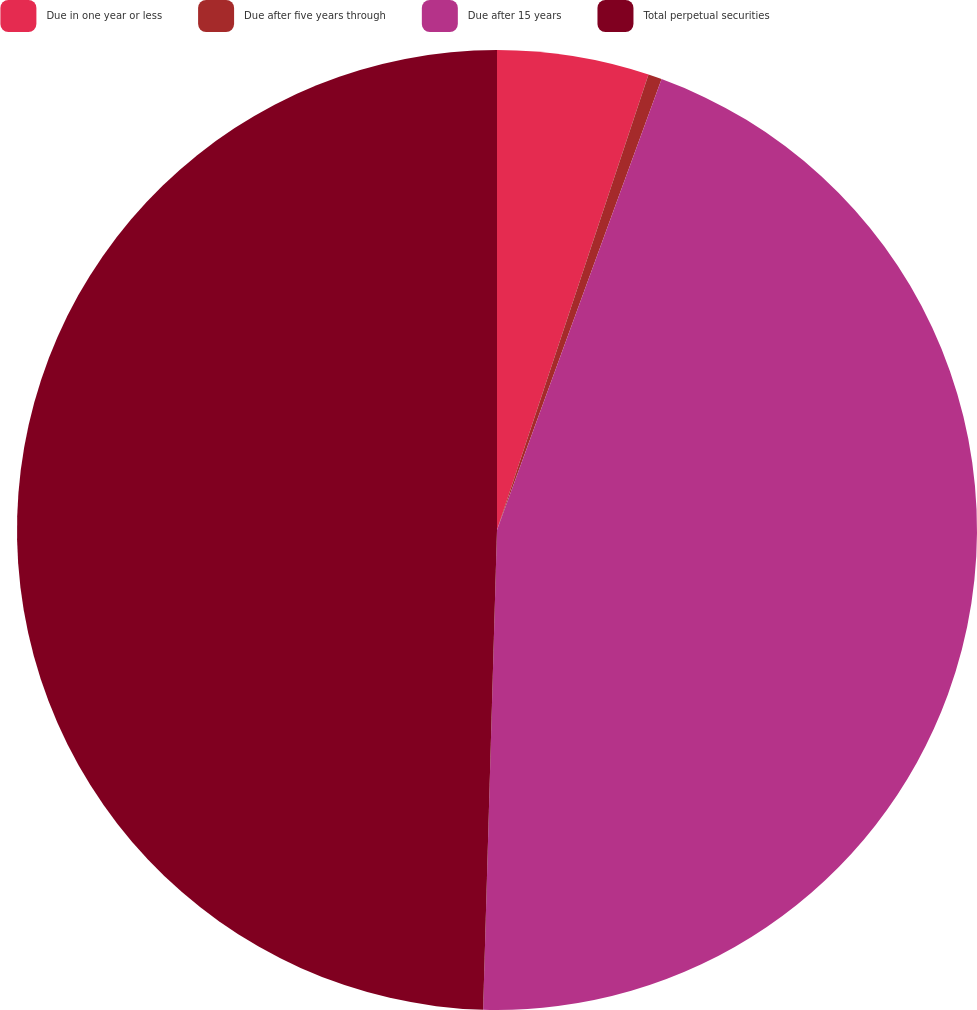<chart> <loc_0><loc_0><loc_500><loc_500><pie_chart><fcel>Due in one year or less<fcel>Due after five years through<fcel>Due after 15 years<fcel>Total perpetual securities<nl><fcel>5.11%<fcel>0.46%<fcel>44.89%<fcel>49.54%<nl></chart> 